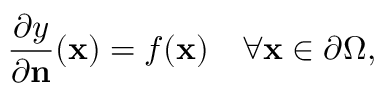Convert formula to latex. <formula><loc_0><loc_0><loc_500><loc_500>{ \frac { \partial y } { \partial n } } ( x ) = f ( x ) \quad \forall x \in \partial \Omega ,</formula> 